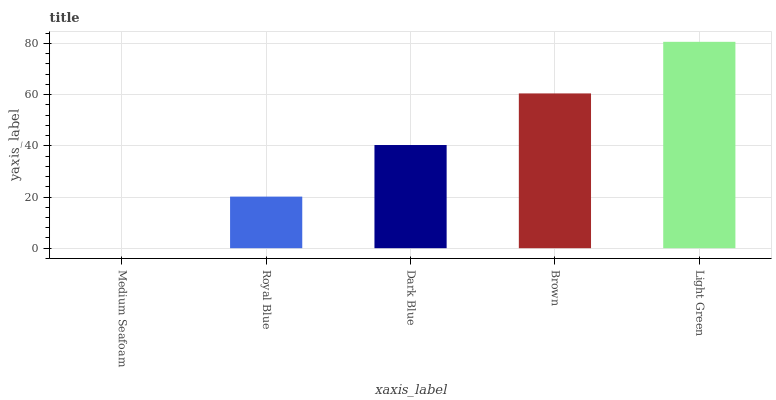Is Medium Seafoam the minimum?
Answer yes or no. Yes. Is Light Green the maximum?
Answer yes or no. Yes. Is Royal Blue the minimum?
Answer yes or no. No. Is Royal Blue the maximum?
Answer yes or no. No. Is Royal Blue greater than Medium Seafoam?
Answer yes or no. Yes. Is Medium Seafoam less than Royal Blue?
Answer yes or no. Yes. Is Medium Seafoam greater than Royal Blue?
Answer yes or no. No. Is Royal Blue less than Medium Seafoam?
Answer yes or no. No. Is Dark Blue the high median?
Answer yes or no. Yes. Is Dark Blue the low median?
Answer yes or no. Yes. Is Light Green the high median?
Answer yes or no. No. Is Royal Blue the low median?
Answer yes or no. No. 